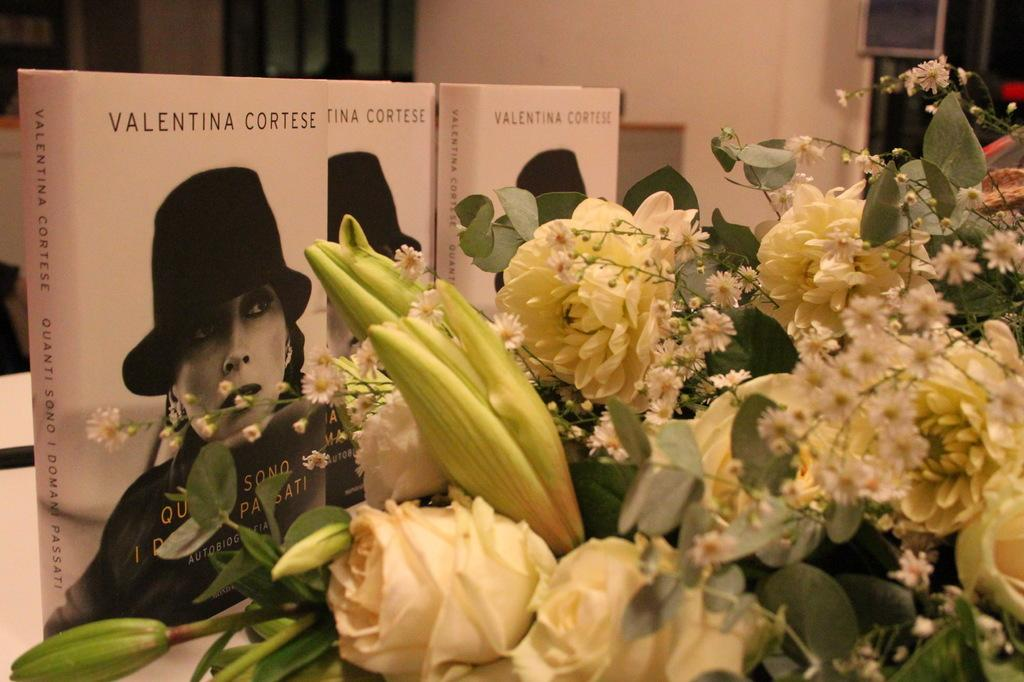What is the main subject in the center of the image? There is a bouquet in the center of the image. What else can be seen on the table in the image? There are books on the table. What is visible in the background of the image? There is a wall, windows, and curtains visible in the background of the image. How many steel legs can be seen supporting the table in the image? There is no mention of steel legs in the provided facts, and therefore we cannot determine the number of legs supporting the table in the image. 